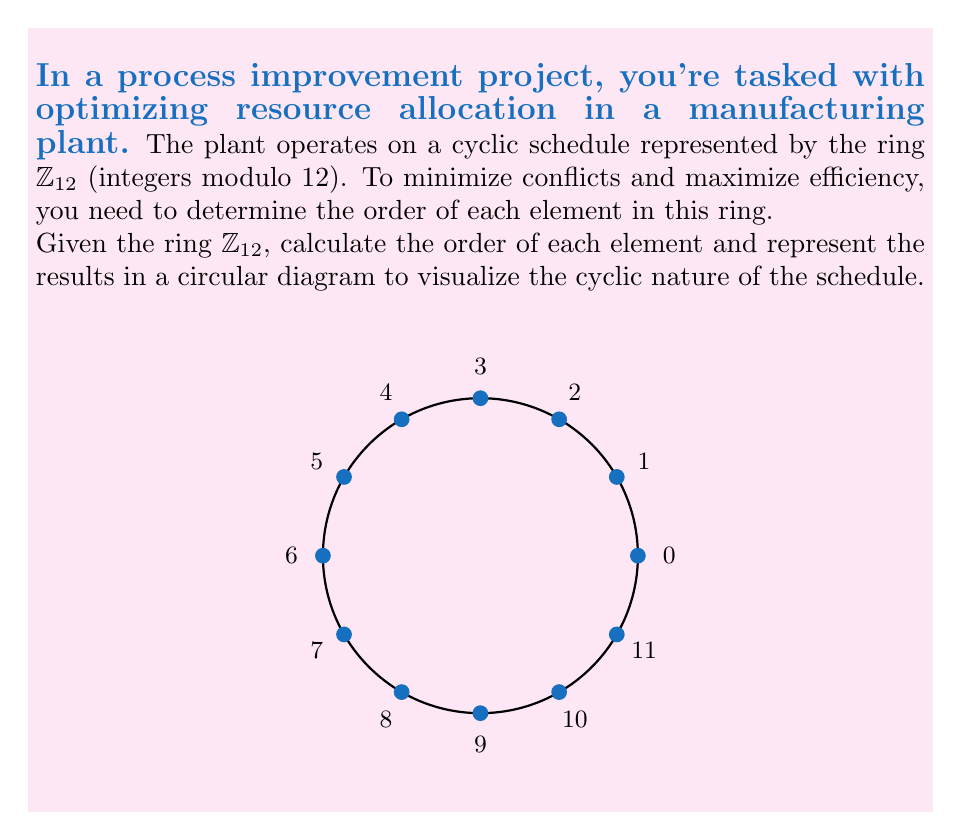Could you help me with this problem? To solve this problem, we'll follow these steps:

1) Recall that the order of an element $a$ in a ring is the smallest positive integer $n$ such that $na = 0$ (in the ring).

2) For each element $k \in \mathbb{Z}_{12}$, we'll find its order:

   For $0$: $1 \cdot 0 = 0$, so order$(0) = 1$

   For $1$: $12 \cdot 1 = 0$ in $\mathbb{Z}_{12}$, so order$(1) = 12$

   For $2$: $6 \cdot 2 = 12 \equiv 0$ in $\mathbb{Z}_{12}$, so order$(2) = 6$

   For $3$: $4 \cdot 3 = 12 \equiv 0$ in $\mathbb{Z}_{12}$, so order$(3) = 4$

   For $4$: $3 \cdot 4 = 12 \equiv 0$ in $\mathbb{Z}_{12}$, so order$(4) = 3$

   For $5$: $12 \cdot 5 = 60 \equiv 0$ in $\mathbb{Z}_{12}$, so order$(5) = 12$

   For $6$: $2 \cdot 6 = 12 \equiv 0$ in $\mathbb{Z}_{12}$, so order$(6) = 2$

   For $7$: $12 \cdot 7 = 84 \equiv 0$ in $\mathbb{Z}_{12}$, so order$(7) = 12$

   For $8$: $3 \cdot 8 = 24 \equiv 0$ in $\mathbb{Z}_{12}$, so order$(8) = 3$

   For $9$: $4 \cdot 9 = 36 \equiv 0$ in $\mathbb{Z}_{12}$, so order$(9) = 4$

   For $10$: $6 \cdot 10 = 60 \equiv 0$ in $\mathbb{Z}_{12}$, so order$(10) = 6$

   For $11$: $12 \cdot 11 = 132 \equiv 0$ in $\mathbb{Z}_{12}$, so order$(11) = 12$

3) We can group elements by their orders:

   Order 1: $\{0\}$
   Order 2: $\{6\}$
   Order 3: $\{4, 8\}$
   Order 4: $\{3, 9\}$
   Order 6: $\{2, 10\}$
   Order 12: $\{1, 5, 7, 11\}$

This grouping can help in optimizing resource allocation by identifying elements with the same cyclic behavior.
Answer: $\{0:1, 1:12, 2:6, 3:4, 4:3, 5:12, 6:2, 7:12, 8:3, 9:4, 10:6, 11:12\}$ 